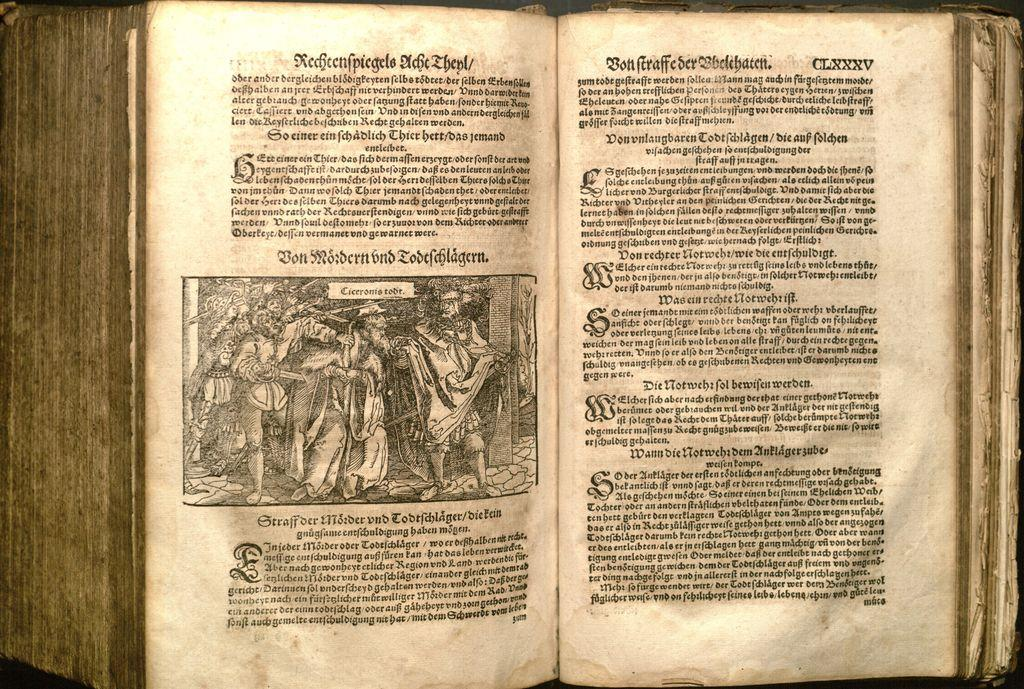What type of object is the main subject in the image? There is an old book in the image. What can be found inside the book? The book has photos and written matter. How does the book feel about being shamed in the image? The book is an inanimate object and cannot feel emotions like shame. 